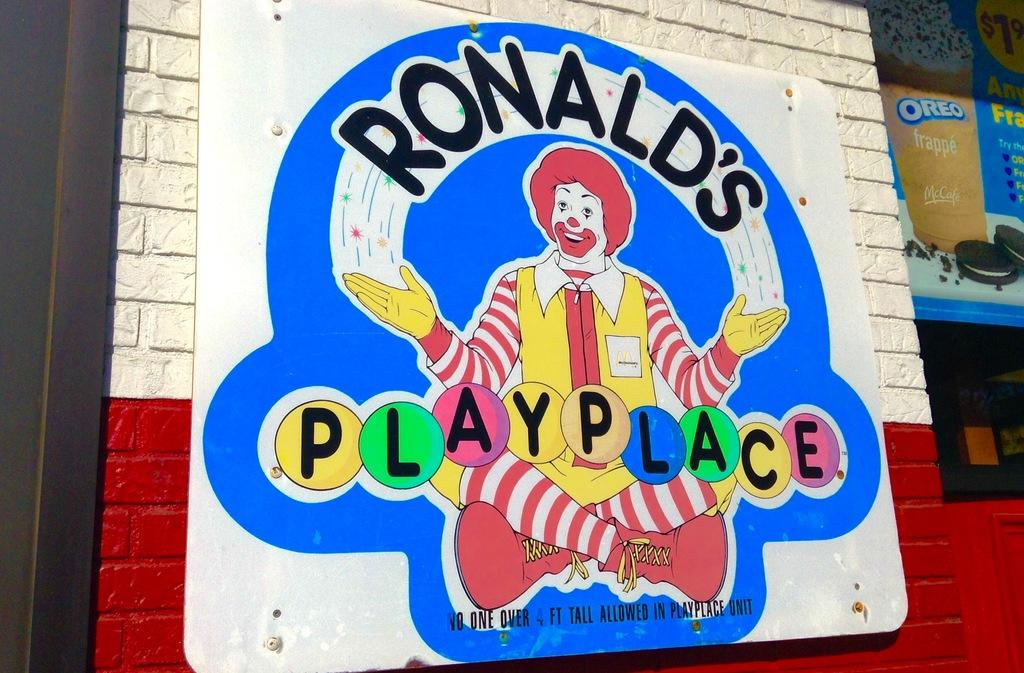What is the main object in the center of the image? There is a board in the center of the image. What is written or depicted on the board? There is text on the board. Are there any characters or symbols on the board? Yes, there is a joker on the board. What can be seen in the background of the image? There are buildings and posters in the background of the image. What type of wood is the board made of in the image? The facts provided do not mention the material of the board, so we cannot determine if it is made of wood or any other material. How much dust can be seen on the joker in the image? There is no mention of dust in the image, so we cannot determine if there is any dust on the joker or any other object in the image. 